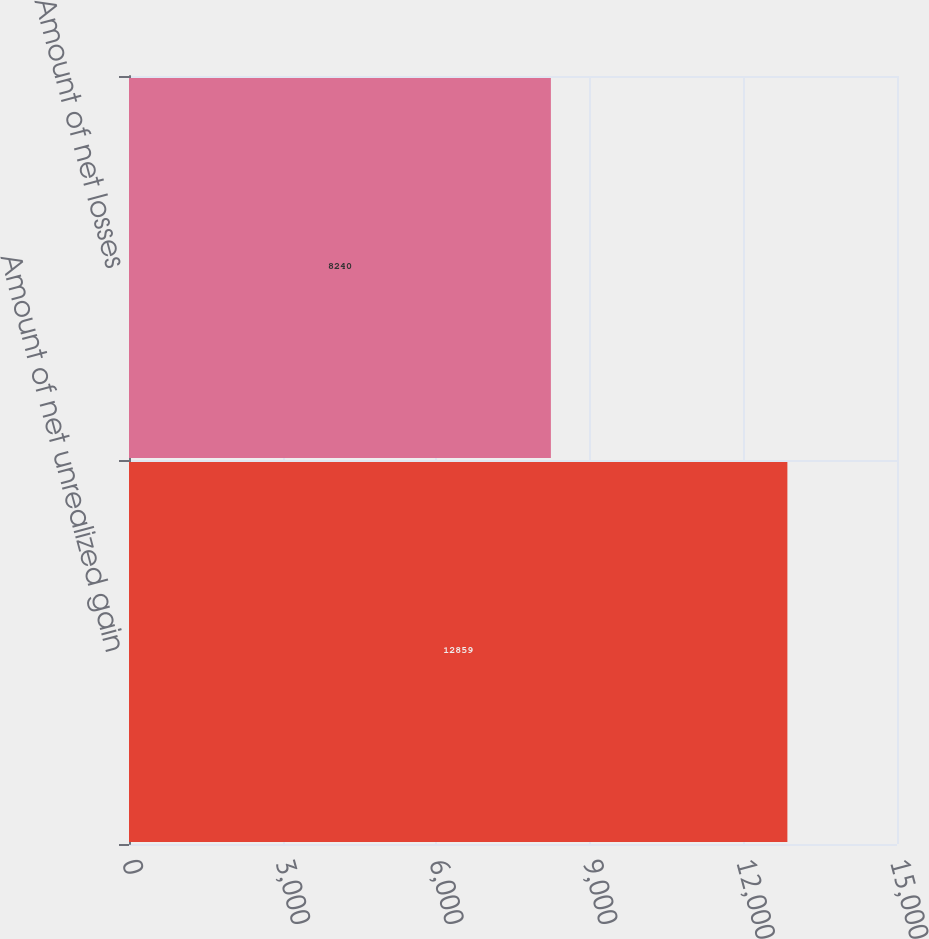Convert chart to OTSL. <chart><loc_0><loc_0><loc_500><loc_500><bar_chart><fcel>Amount of net unrealized gain<fcel>Amount of net losses<nl><fcel>12859<fcel>8240<nl></chart> 